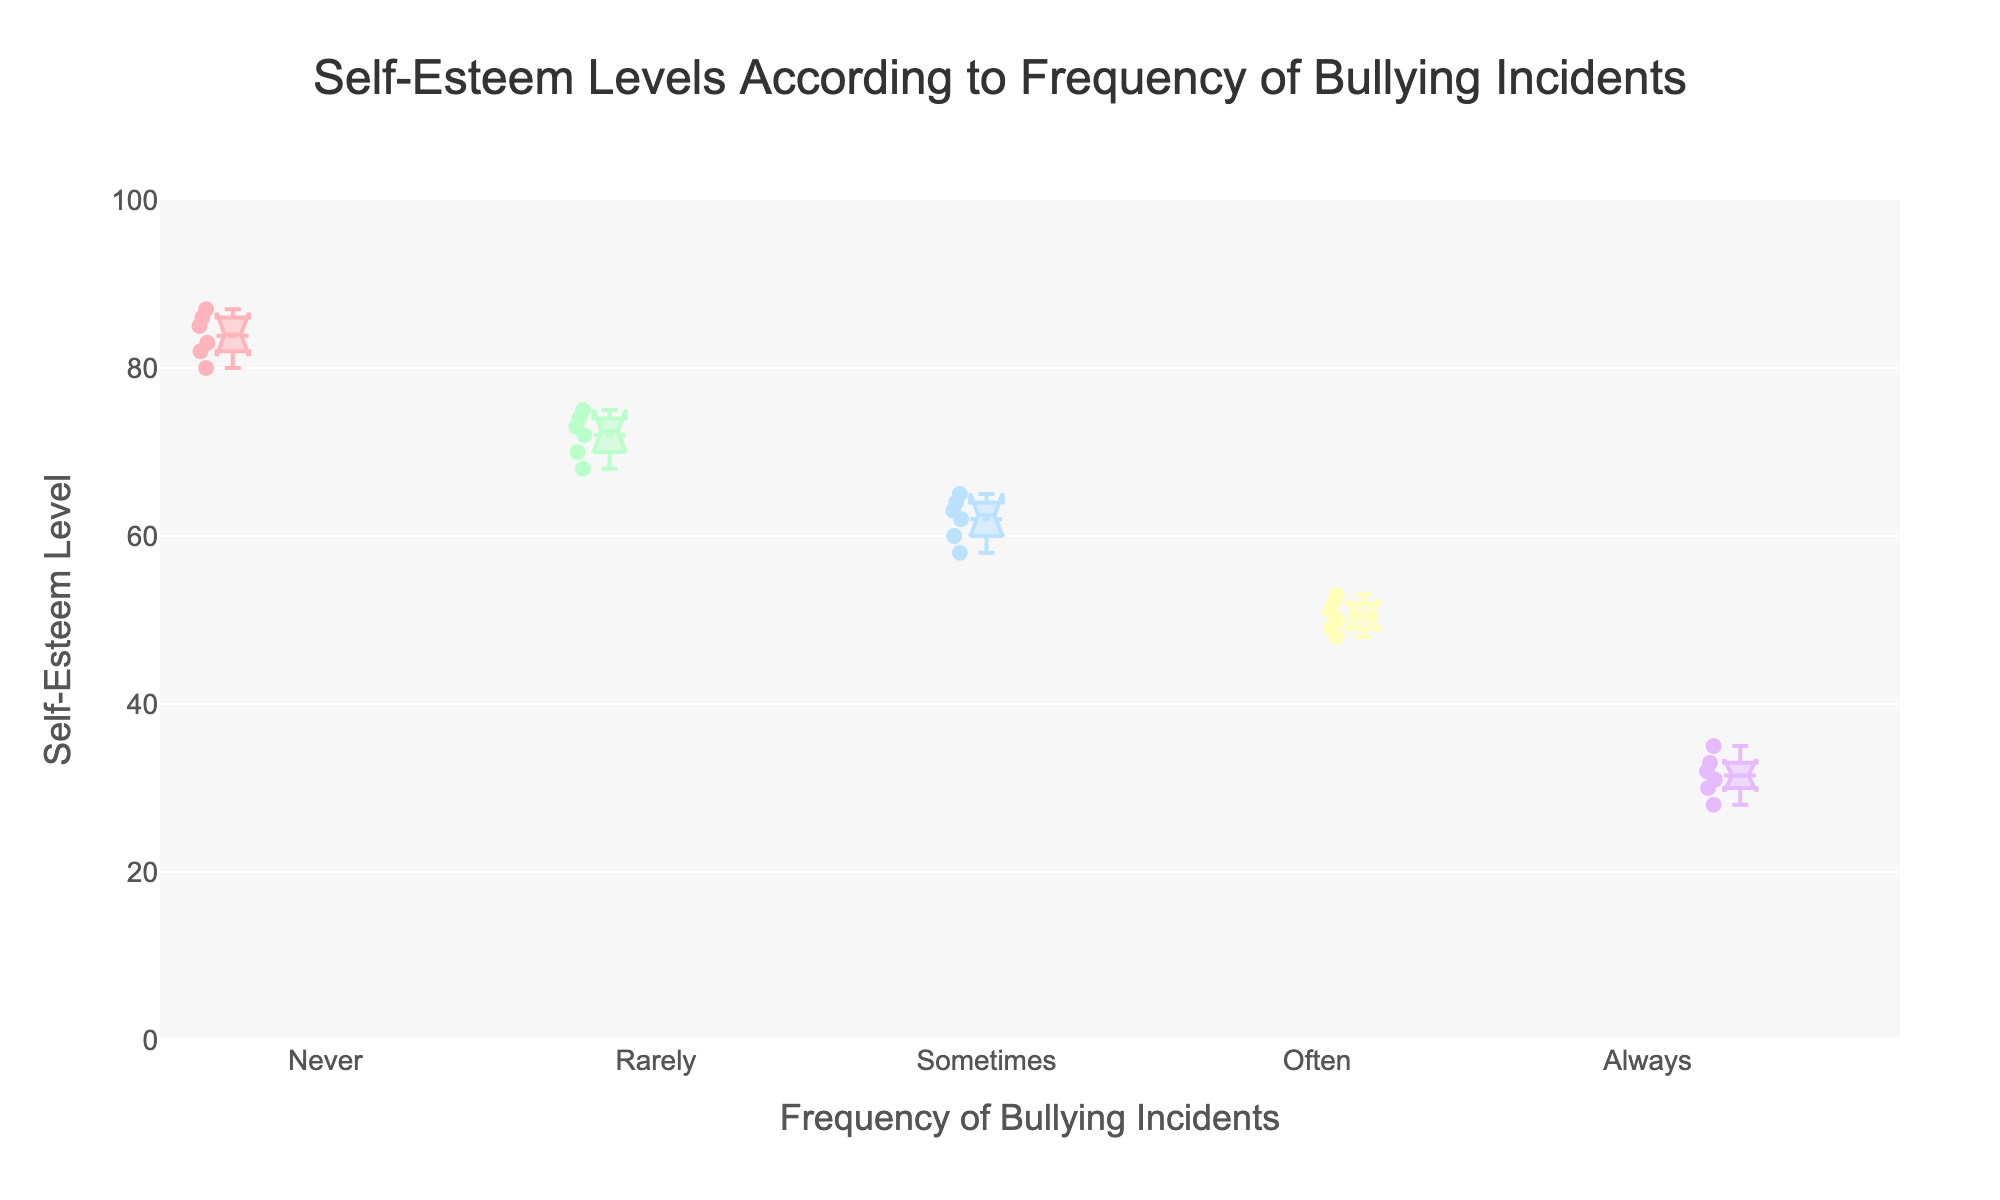what's the title of the plot? The title is located at the top center of the plot and provides a brief description of the content. It reads 'Self-Esteem Levels According to Frequency of Bullying Incidents'.
Answer: Self-Esteem Levels According to Frequency of Bullying Incidents what are the axis titles? The axis titles help to understand what each axis represents. The x-axis title reads 'Frequency of Bullying Incidents' and the y-axis title reads 'Self-Esteem Level'.
Answer: Frequency of Bullying Incidents (x-axis), Self-Esteem Level (y-axis) how many categories are there for the frequency of bullying incidents? Each box plot represents a category for the frequency of bullying incidents. By counting these box plots, we find there are five categories.
Answer: Five categories which frequency of bullying incidents category has the highest median self-esteem level? The median self-esteem level is represented by the line inside each box. The 'Never' category has the highest median self-esteem level, as the line inside its box is higher than in other boxes.
Answer: Never what is the interquartile range (IQR) for the 'Rarely' category? The IQR is the range between the first quartile (Q1) and the third quartile (Q3). For the 'Rarely' category, examine the box's lower and upper boundaries. The IQR is the difference between these two values.
Answer: The IQR for 'Rarely' is 70-74 how does the self-esteem level change as the frequency of bullying increases? Observing the plot, as the frequency of bullying incidents increases from 'Never' to 'Always', the medians and the overall distribution of self-esteem levels decrease.
Answer: Decreases what is the lowest self-esteem level recorded in the dataset and for which category? The lowest self-esteem level can be found by identifying the lowest point across all categories, which is seen in the 'Always' category box plot.
Answer: 28 in the 'Always' category which category exhibits the widest spread of self-esteem levels? The spread is the distance between the smallest and largest values in each box plot. By comparing the ranges, the 'Never' category shows the widest spread.
Answer: Never are there any overlapping notches between categories, indicating that their medians do not significantly differ? Overlapping notches on the boxes suggest the medians between categories are not significantly different. No overlapping notches are visible, indicating significant differences in medians among categories.
Answer: No overlapping notches which category has the smallest spread in self-esteem levels? The category with the smallest spread has the closest minimum and maximum values. Inspecting each box plot's range shows that 'Always' has the smallest spread.
Answer: Always 